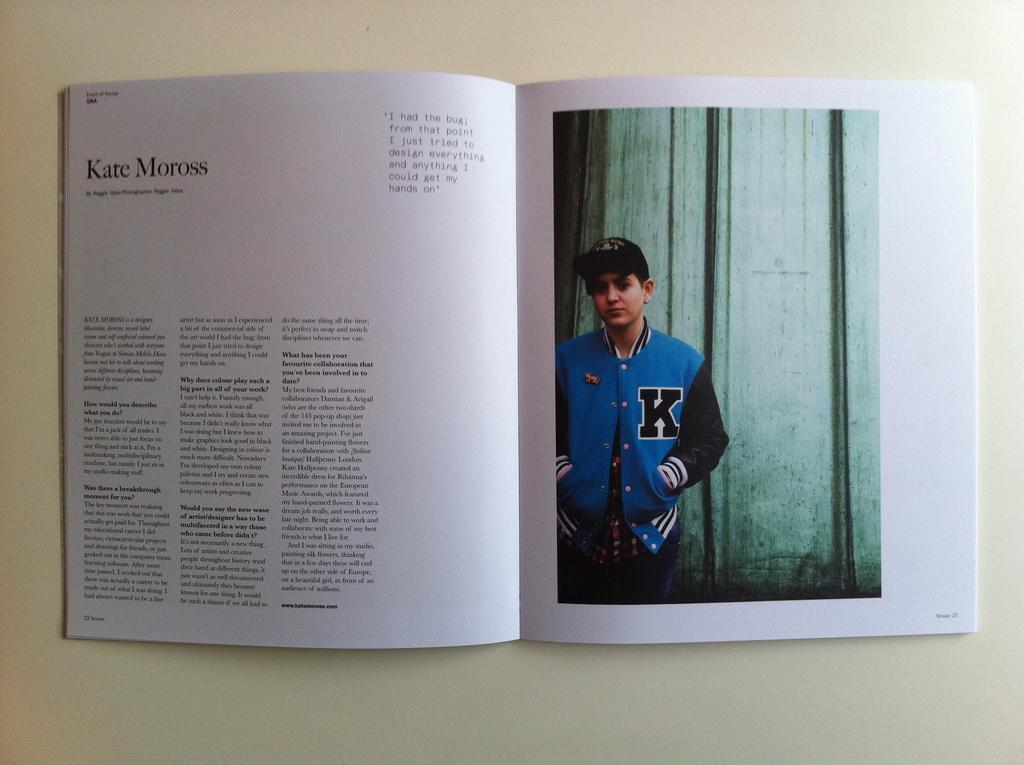<image>
Describe the image concisely. A book is open to a page about Kate Moross with a picture of a young boy. 